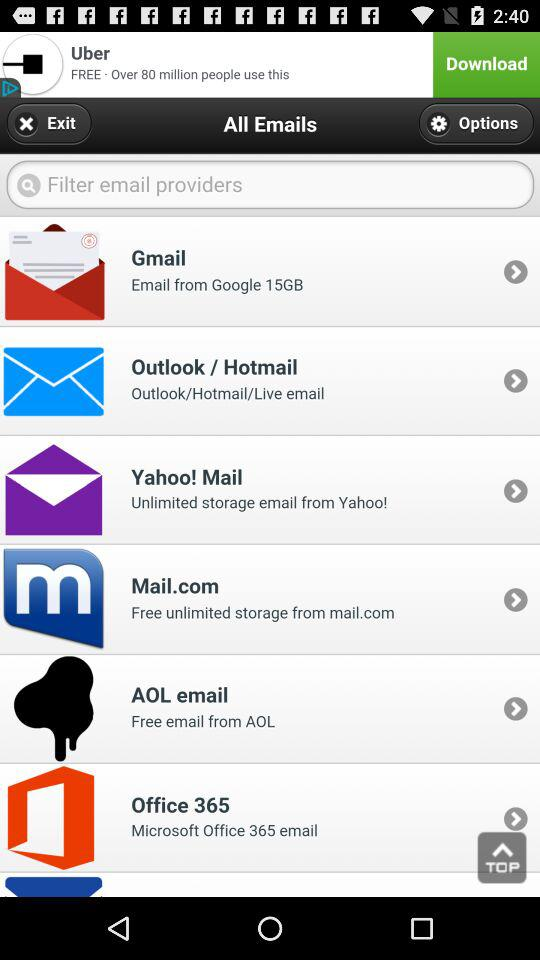What is the size of the emails from Google? The size is 15GB. 